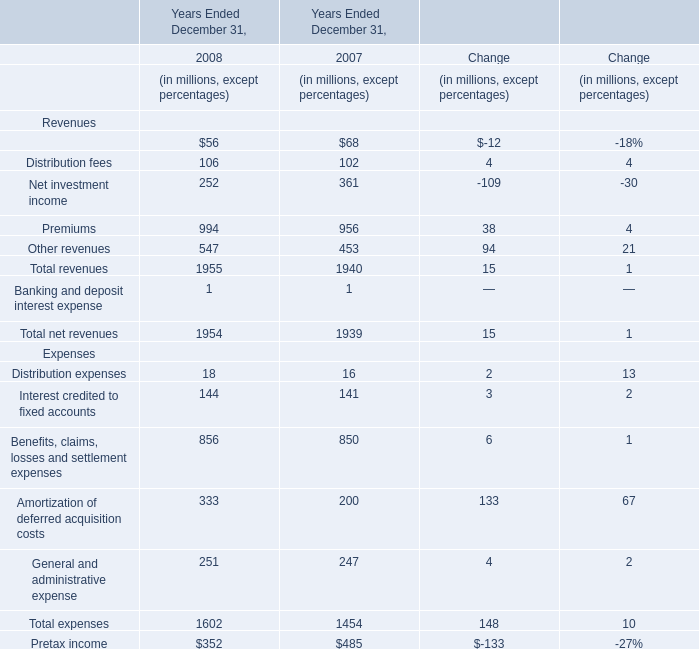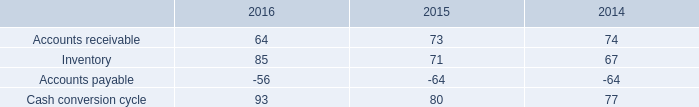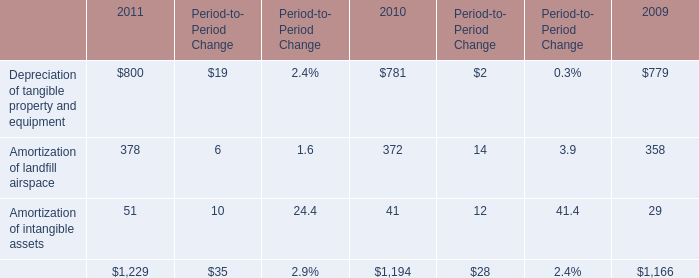What is the sum of Premiums in 2008 and Amortization of landfill airspace in 2011? (in million) 
Computations: (994 + 378)
Answer: 1372.0. 